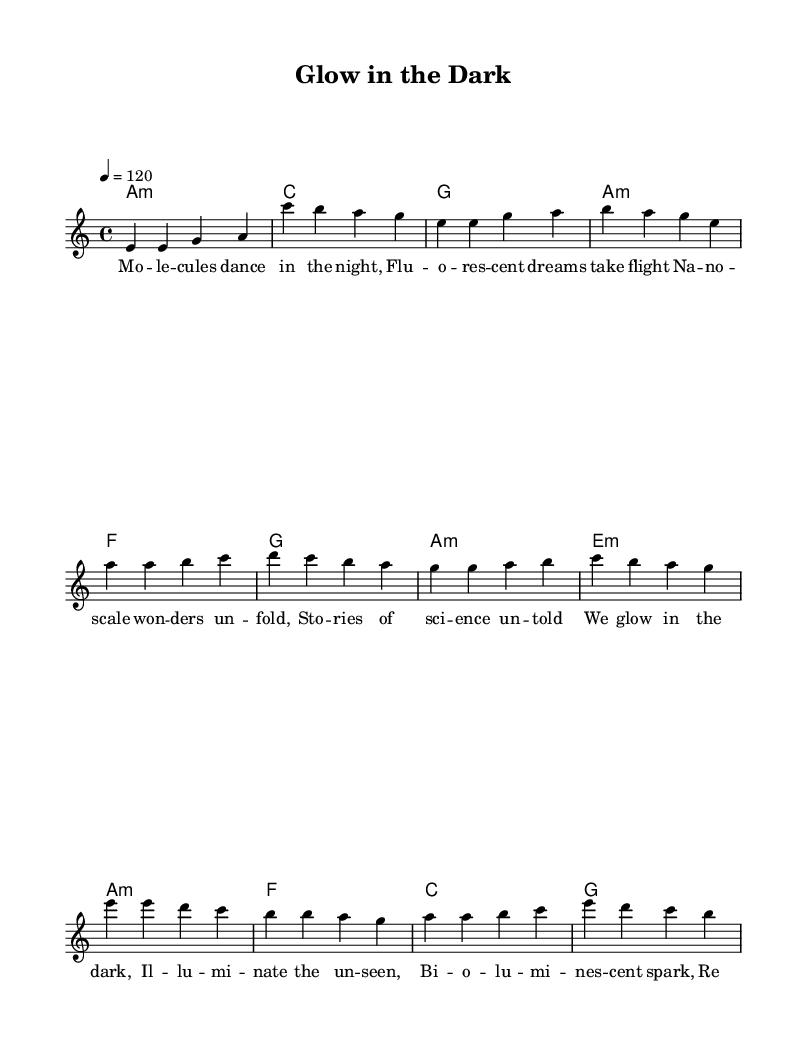What is the key signature of this music? The key signature is A minor, which has no sharps or flats. A minor is the relative minor of C major.
Answer: A minor What is the time signature of this sheet music? The time signature is indicated as 4/4, which means there are four beats per measure, and a quarter note gets one beat.
Answer: 4/4 What is the tempo marking for this piece? The tempo marking is set to 120 beats per minute, indicated by "4 = 120." This means the quarter note is played at 120 beats per minute.
Answer: 120 How many measures are in the verse? The verse consists of four measures, as indicated by the grouping of notes in the melody section.
Answer: 4 What type of harmony is used in the chorus? The harmony employed in the chorus includes minor and major chords, with a structure that emphasizes the A minor chord followed by F, C, and G.
Answer: Minor and major chords Which section of the song has the lyrics about "nano-scale wonders"? The lyrics about "nano-scale wonders" are found in the pre-chorus, which precedes the chorus. This section specifically explores themes of science and discovery.
Answer: Pre-Chorus What is the first note of the melody in the chorus? The first note of the melody in the chorus is E, which starts the melodic phrase focused on illuminating the unseen.
Answer: E 